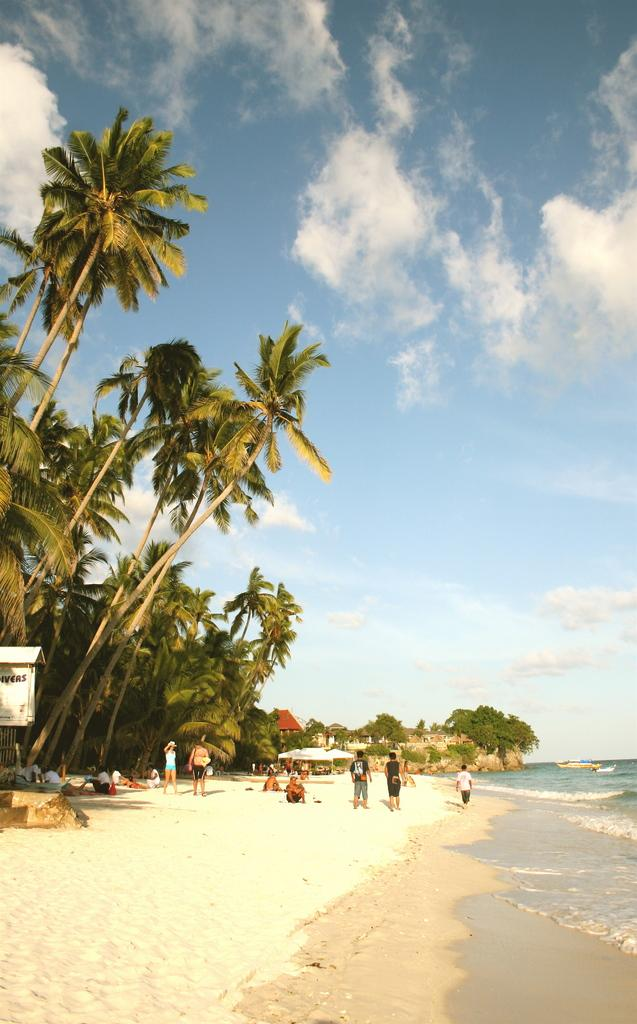How many people are in the image? There is a group of people in the image. What are some of the people in the image doing? Some people are walking, and some people are sitting. What can be seen in the background of the image? There are trees and water visible in the background of the image. What is the color of the trees in the image? The trees are green. What is the color of the sky in the image? The sky is blue and white. What grade did the people in the image receive for their behavior? There is no indication of grades or behavior in the image; it simply shows a group of people, some walking and some sitting, with a background of trees, water, and a blue and white sky. 